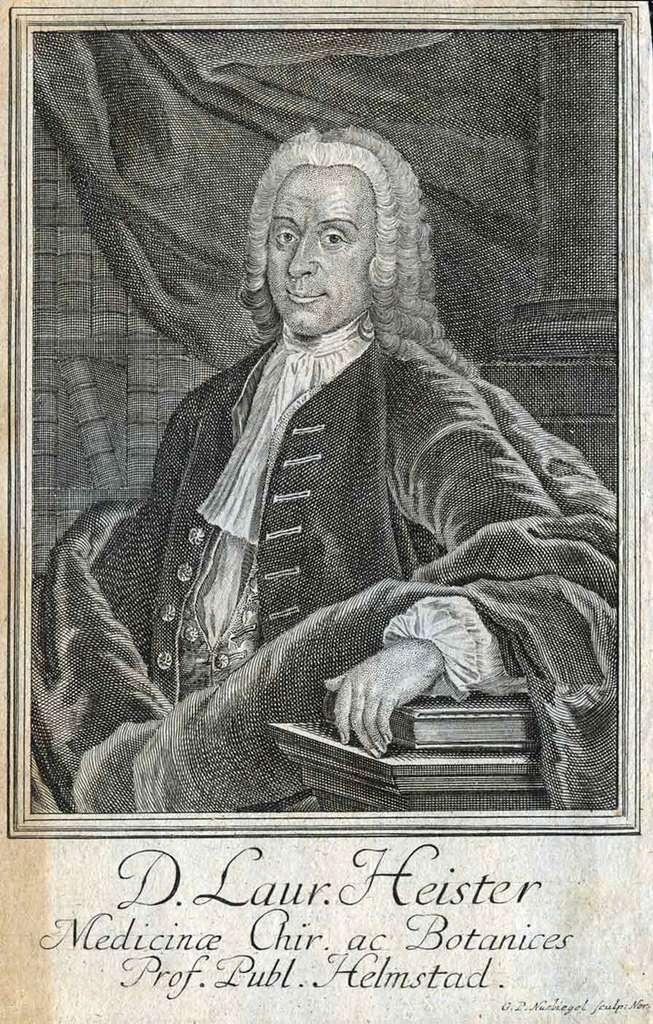What is the main subject of the image? There is a picture of a person in the image. What else can be seen near the person? There are books beside the person. Is there any text in the image? Yes, there is text at the bottom of the image. What is the color scheme of the image? The image is black and white. Can you describe the cave in the image? There is no cave present in the image. What type of sea creatures can be seen in the image? There are no sea creatures present in the image. 